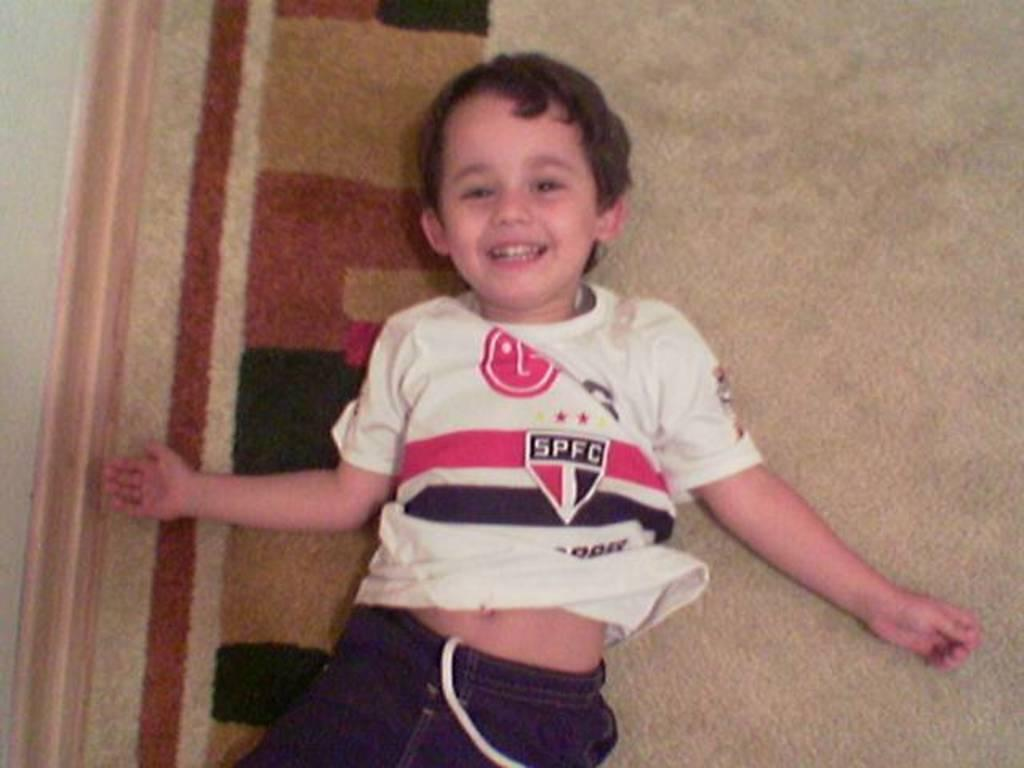<image>
Share a concise interpretation of the image provided. A kid wearing a shirt with the logo SPFC 